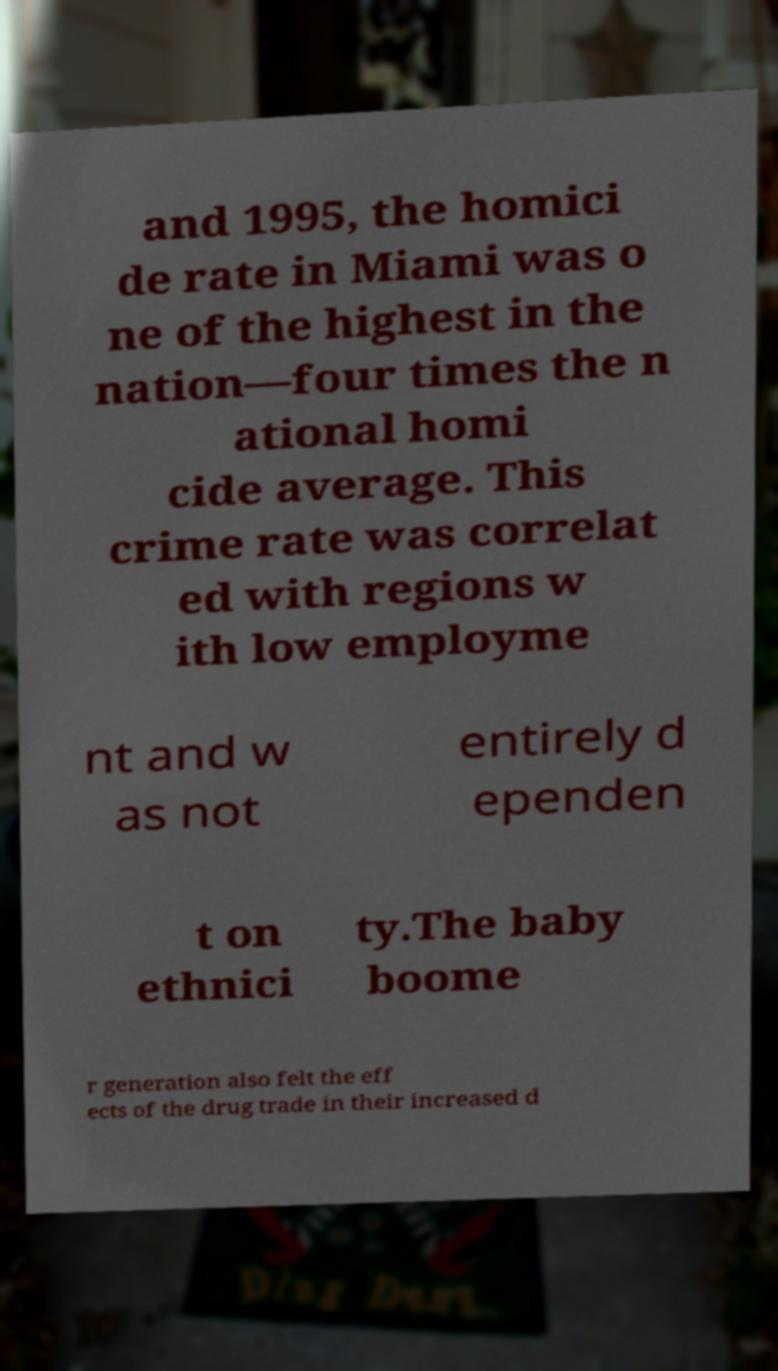There's text embedded in this image that I need extracted. Can you transcribe it verbatim? and 1995, the homici de rate in Miami was o ne of the highest in the nation—four times the n ational homi cide average. This crime rate was correlat ed with regions w ith low employme nt and w as not entirely d ependen t on ethnici ty.The baby boome r generation also felt the eff ects of the drug trade in their increased d 